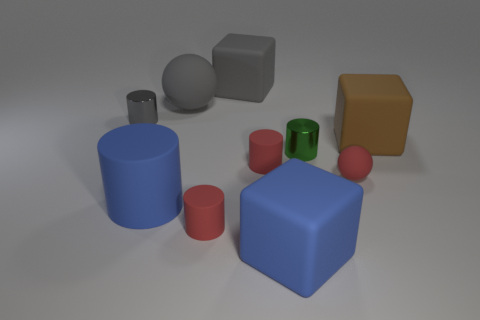Subtract all red cylinders. How many were subtracted if there are1red cylinders left? 1 Subtract all red balls. How many balls are left? 1 Subtract all large blue blocks. How many blocks are left? 2 Subtract 1 spheres. How many spheres are left? 1 Subtract all blue blocks. Subtract all gray cylinders. How many blocks are left? 2 Subtract all purple cylinders. How many brown cubes are left? 1 Subtract all big rubber cylinders. Subtract all large gray cubes. How many objects are left? 8 Add 6 brown matte cubes. How many brown matte cubes are left? 7 Add 3 blue cylinders. How many blue cylinders exist? 4 Subtract 0 purple spheres. How many objects are left? 10 